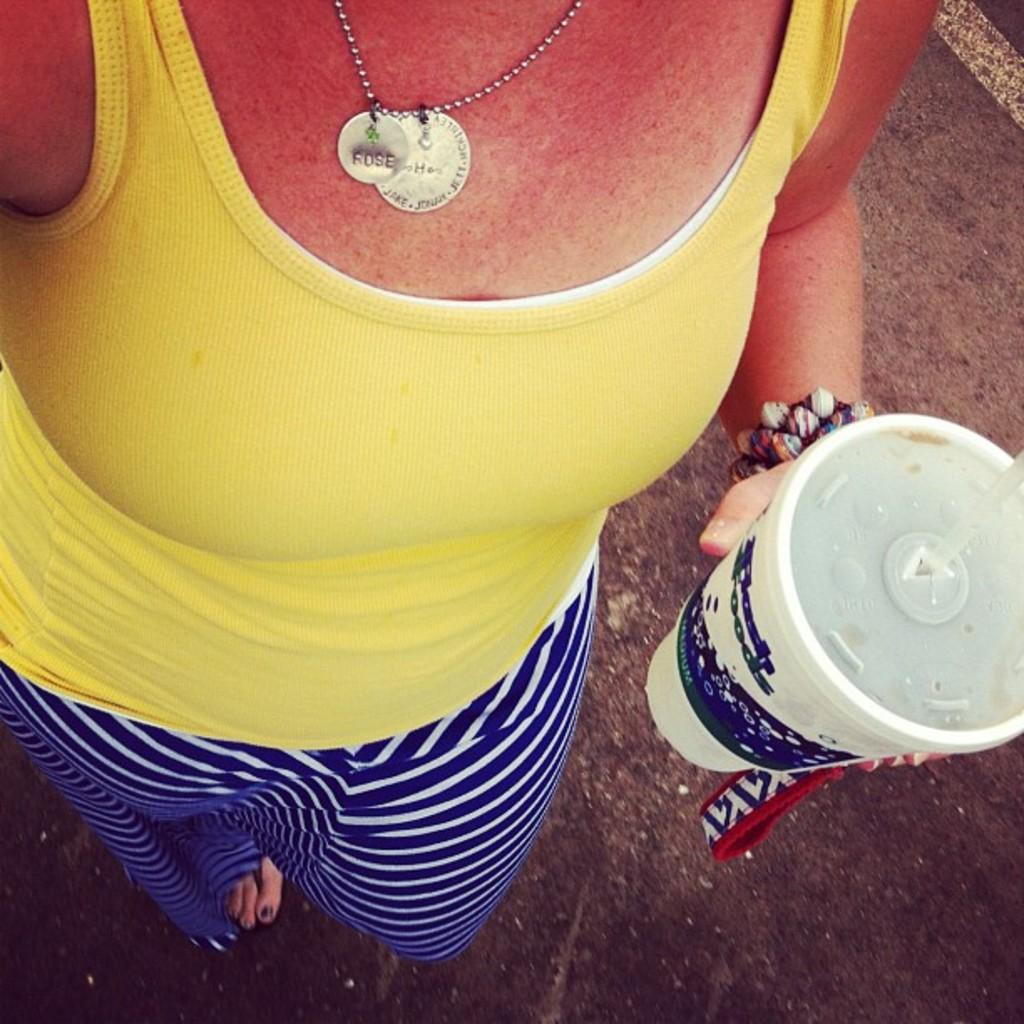Who or what is present in the image? There is a person in the image. Where is the person located? The person is standing on the road. What is the person holding in the image? The person is holding a cup. What type of snow is being controlled by the person in the image? There is no snow present in the image, and the person is not controlling anything. 